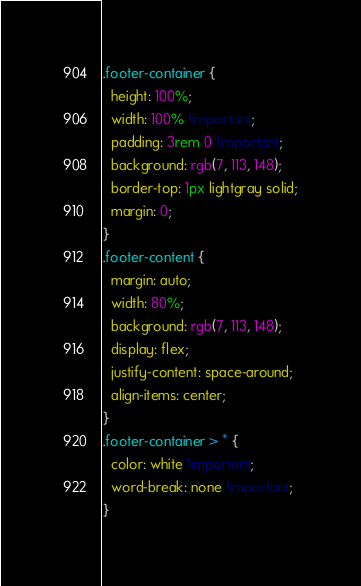<code> <loc_0><loc_0><loc_500><loc_500><_CSS_>.footer-container {
  height: 100%;
  width: 100% !important;
  padding: 3rem 0 !important;
  background: rgb(7, 113, 148);
  border-top: 1px lightgray solid;
  margin: 0;
}
.footer-content {
  margin: auto;
  width: 80%;
  background: rgb(7, 113, 148);
  display: flex;
  justify-content: space-around;
  align-items: center;
}
.footer-container > * {
  color: white !important;
  word-break: none !important;
}
</code> 